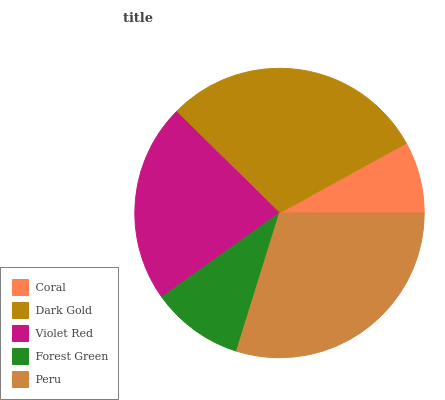Is Coral the minimum?
Answer yes or no. Yes. Is Peru the maximum?
Answer yes or no. Yes. Is Dark Gold the minimum?
Answer yes or no. No. Is Dark Gold the maximum?
Answer yes or no. No. Is Dark Gold greater than Coral?
Answer yes or no. Yes. Is Coral less than Dark Gold?
Answer yes or no. Yes. Is Coral greater than Dark Gold?
Answer yes or no. No. Is Dark Gold less than Coral?
Answer yes or no. No. Is Violet Red the high median?
Answer yes or no. Yes. Is Violet Red the low median?
Answer yes or no. Yes. Is Coral the high median?
Answer yes or no. No. Is Dark Gold the low median?
Answer yes or no. No. 